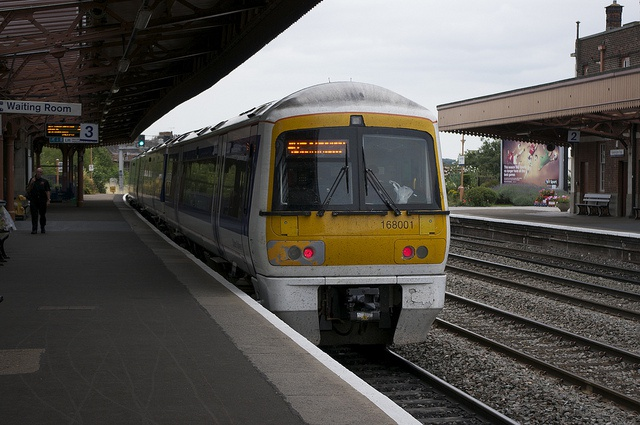Describe the objects in this image and their specific colors. I can see train in black, gray, darkgray, and olive tones, people in black and gray tones, and bench in black and gray tones in this image. 